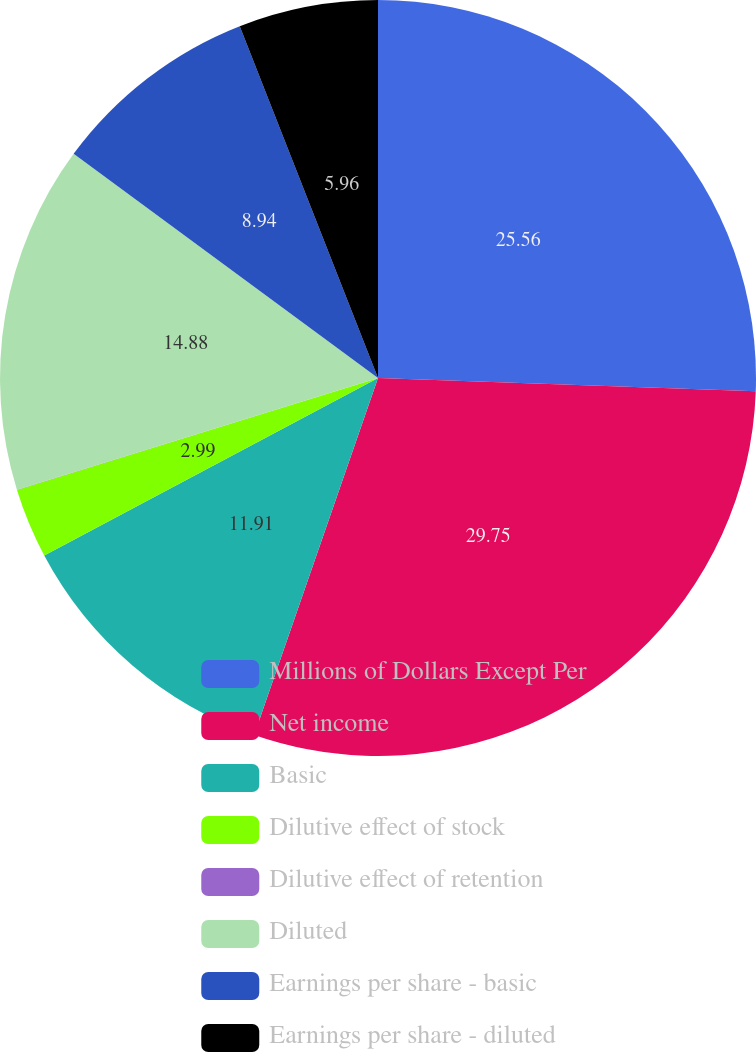Convert chart. <chart><loc_0><loc_0><loc_500><loc_500><pie_chart><fcel>Millions of Dollars Except Per<fcel>Net income<fcel>Basic<fcel>Dilutive effect of stock<fcel>Dilutive effect of retention<fcel>Diluted<fcel>Earnings per share - basic<fcel>Earnings per share - diluted<nl><fcel>25.56%<fcel>29.76%<fcel>11.91%<fcel>2.99%<fcel>0.01%<fcel>14.88%<fcel>8.94%<fcel>5.96%<nl></chart> 